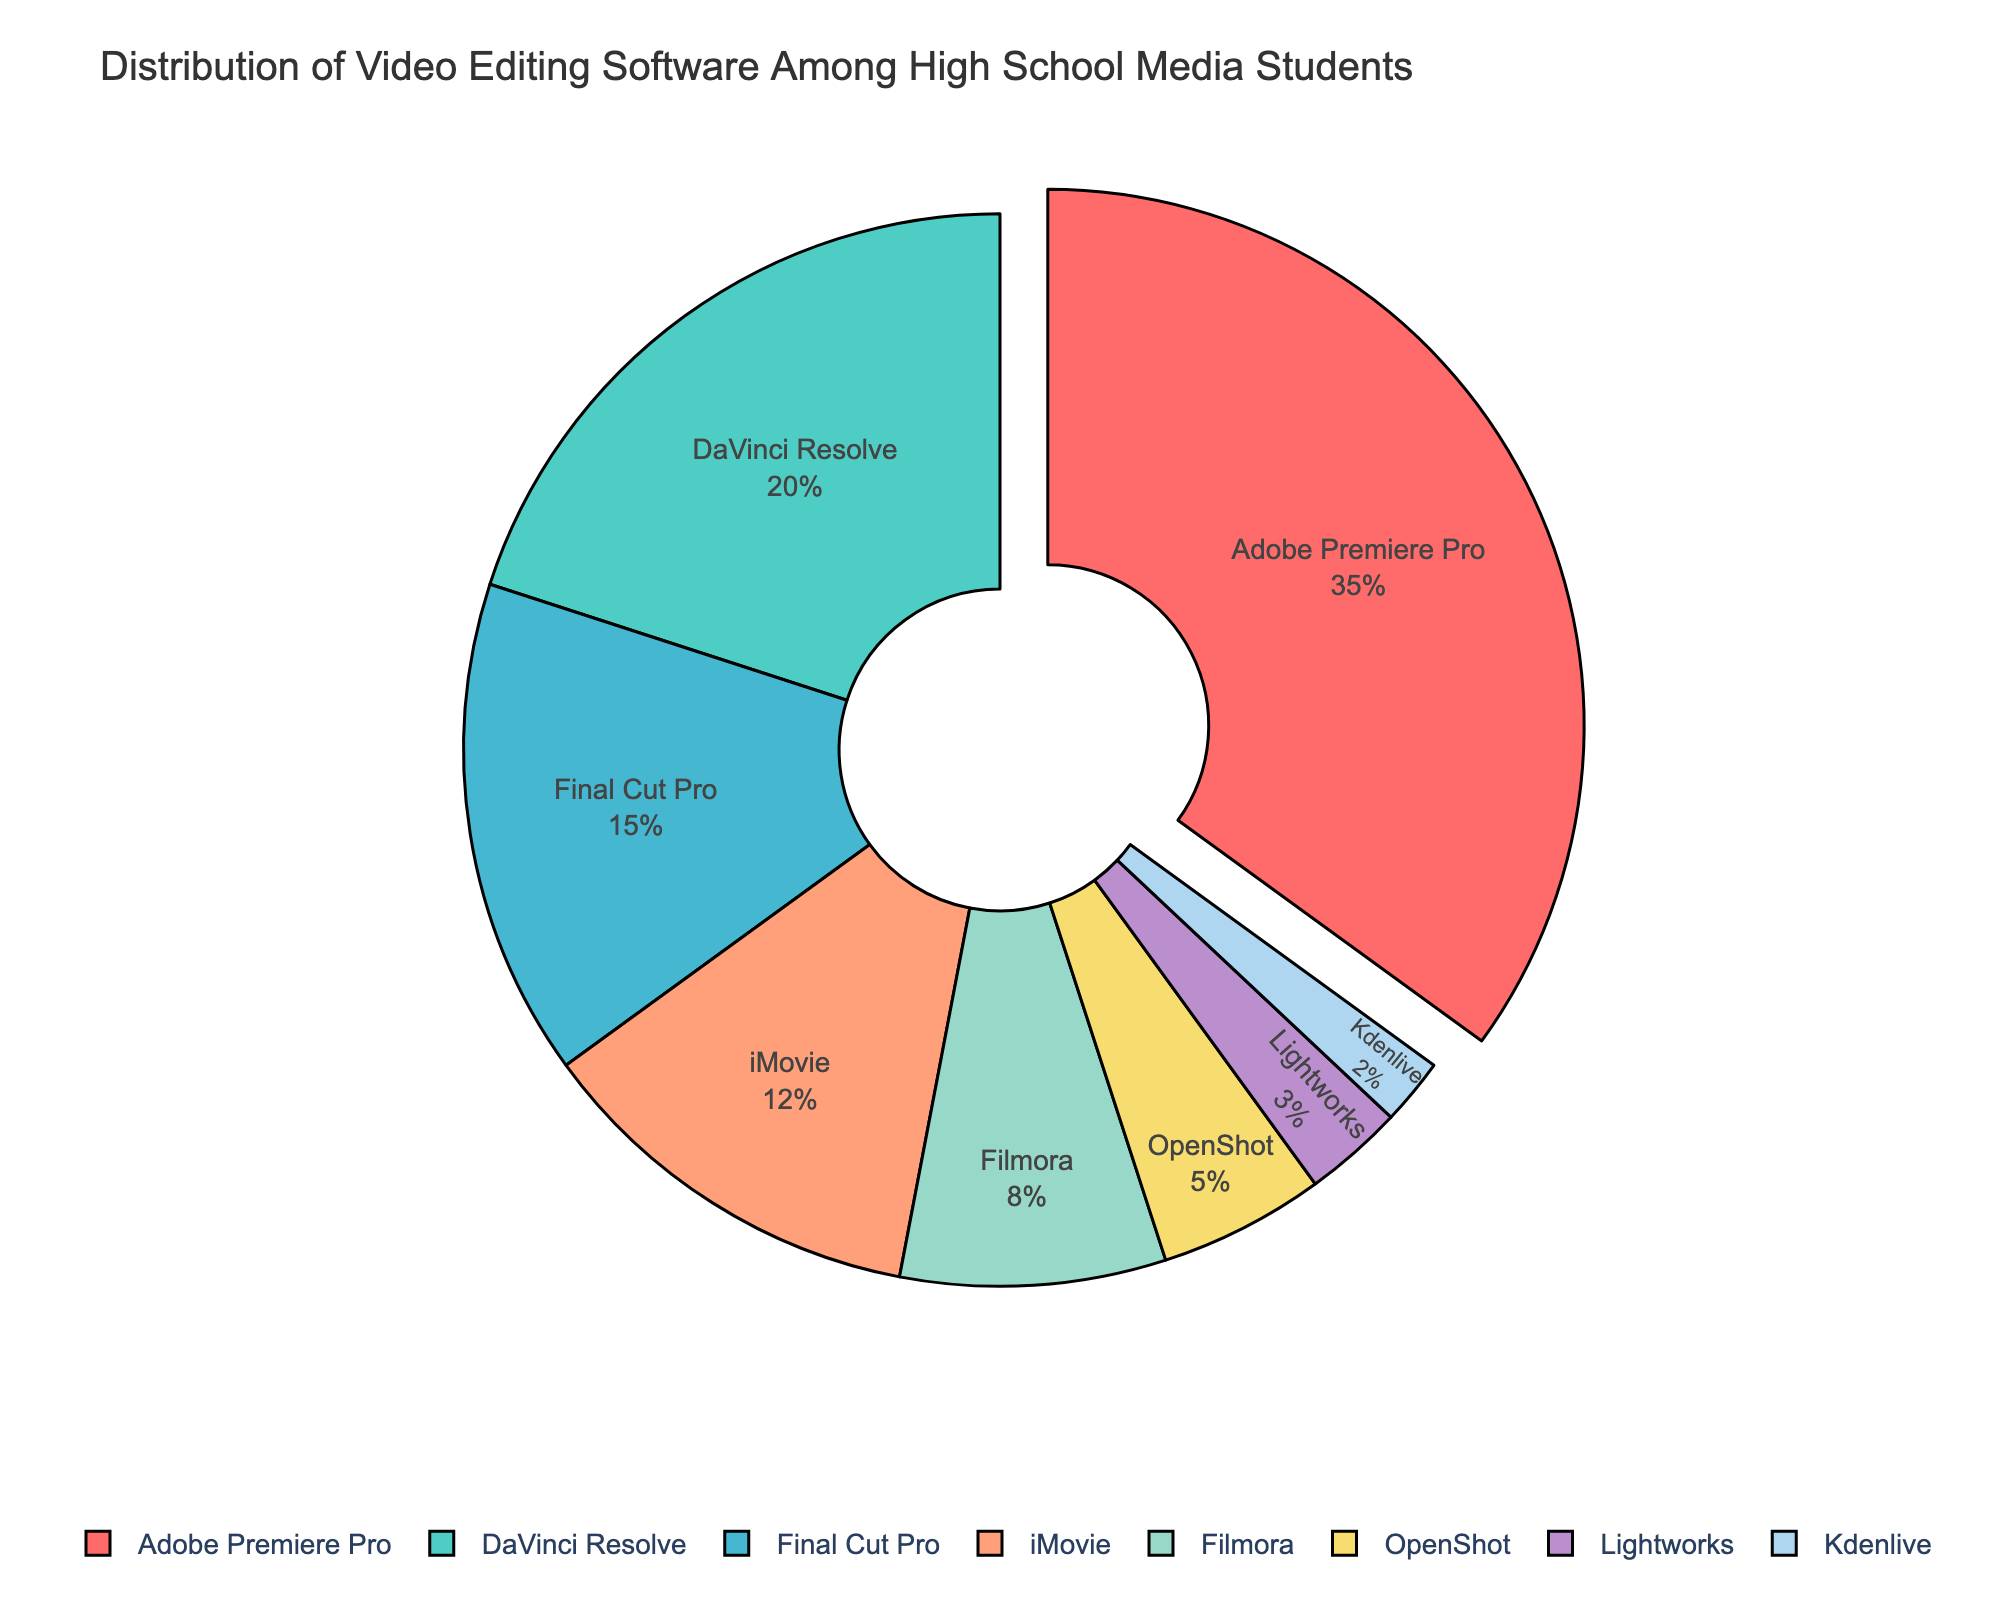What percentage of students use Adobe Premiere Pro? Refer to the figure, the segment labeled "Adobe Premiere Pro" represents 35% of the total distribution.
Answer: 35% Which software has the second highest usage among high school media students? Based on the figure, after Adobe Premiere Pro, DaVinci Resolve comes as the second highest with 20% usage.
Answer: DaVinci Resolve How does the usage of iMovie compare to that of Filmora? From the figure, iMovie has a 12% usage, while Filmora has an 8% usage. To compare, subtract 8 from 12, which gives 4. iMovie is used 4% more than Filmora.
Answer: iMovie is used 4% more What is the combined percentage of students using OpenShot and Lightworks? From the figure, OpenShot shows 5% and Lightworks shows 3%. Adding these together, 5 + 3 = 8.
Answer: 8% Which software is represented with the smallest segment, and what is its percentage? The smallest segment in the figure corresponds to Kdenlive with a 2% usage.
Answer: Kdenlive, 2% What is the color used to represent Final Cut Pro in the pie chart? The segment for Final Cut Pro is colored light orange in the pie chart.
Answer: light orange What is the total percentage of students using either Final Cut Pro or iMovie? Based on the figure, Final Cut Pro has 15% and iMovie has 12%. Adding these together, 15 + 12 = 27.
Answer: 27% How much more popular is Adobe Premiere Pro than iMovie? Adobe Premiere Pro has 35% usage, while iMovie has 12%. Subtracting these values, 35 - 12 = 23.
Answer: 23% Which software segments are pulled out from the pie chart, and how many are there? The pie chart shows one segment pulled out, which is labeled "Adobe Premiere Pro".
Answer: 1, Adobe Premiere Pro 